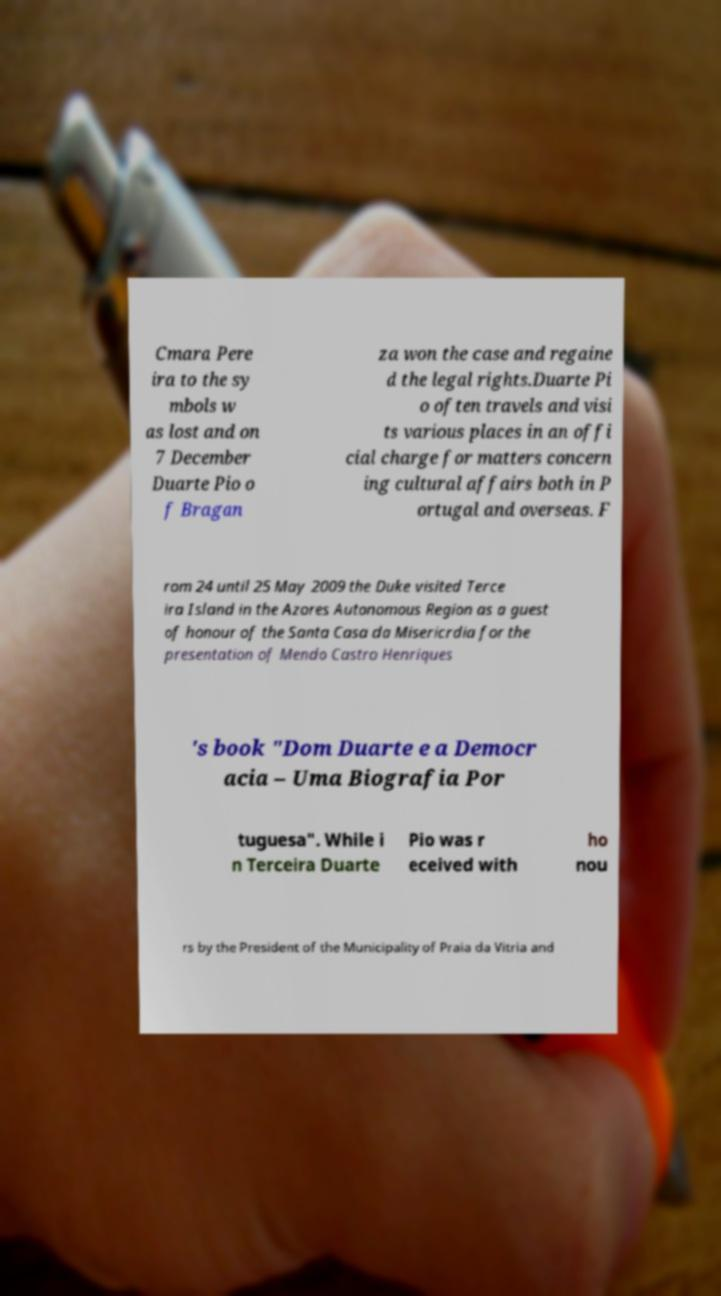Could you assist in decoding the text presented in this image and type it out clearly? Cmara Pere ira to the sy mbols w as lost and on 7 December Duarte Pio o f Bragan za won the case and regaine d the legal rights.Duarte Pi o often travels and visi ts various places in an offi cial charge for matters concern ing cultural affairs both in P ortugal and overseas. F rom 24 until 25 May 2009 the Duke visited Terce ira Island in the Azores Autonomous Region as a guest of honour of the Santa Casa da Misericrdia for the presentation of Mendo Castro Henriques 's book "Dom Duarte e a Democr acia – Uma Biografia Por tuguesa". While i n Terceira Duarte Pio was r eceived with ho nou rs by the President of the Municipality of Praia da Vitria and 